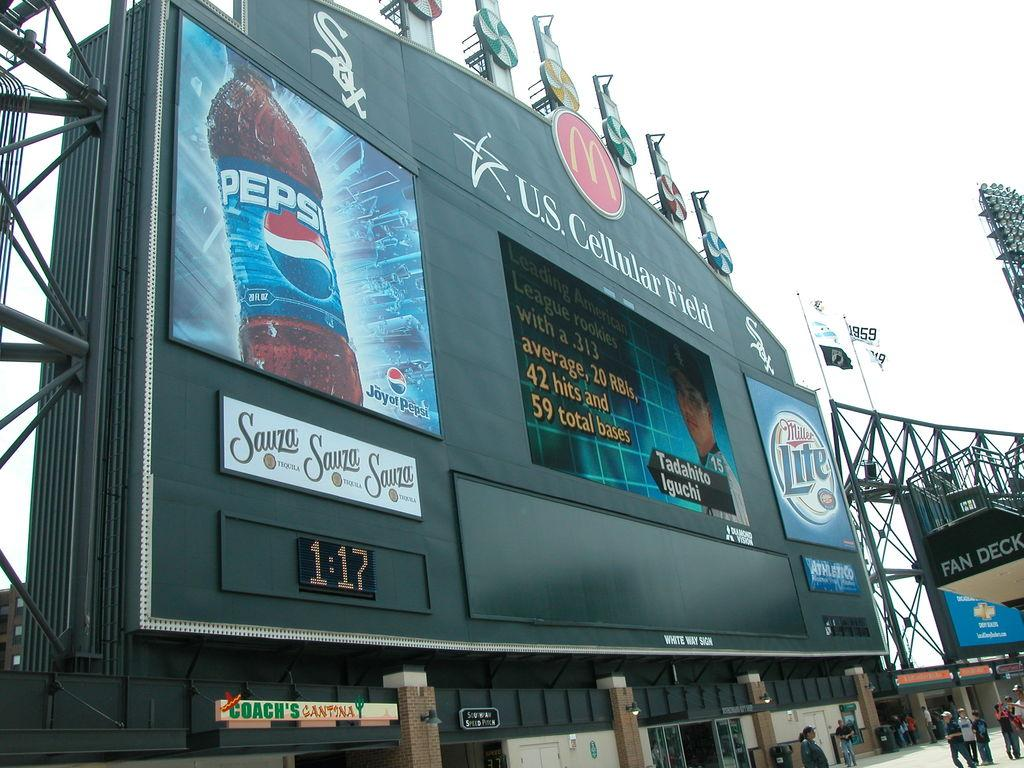<image>
Describe the image concisely. An advertisement on the U.S Cellular Field displaying an ad for Pepsi. 